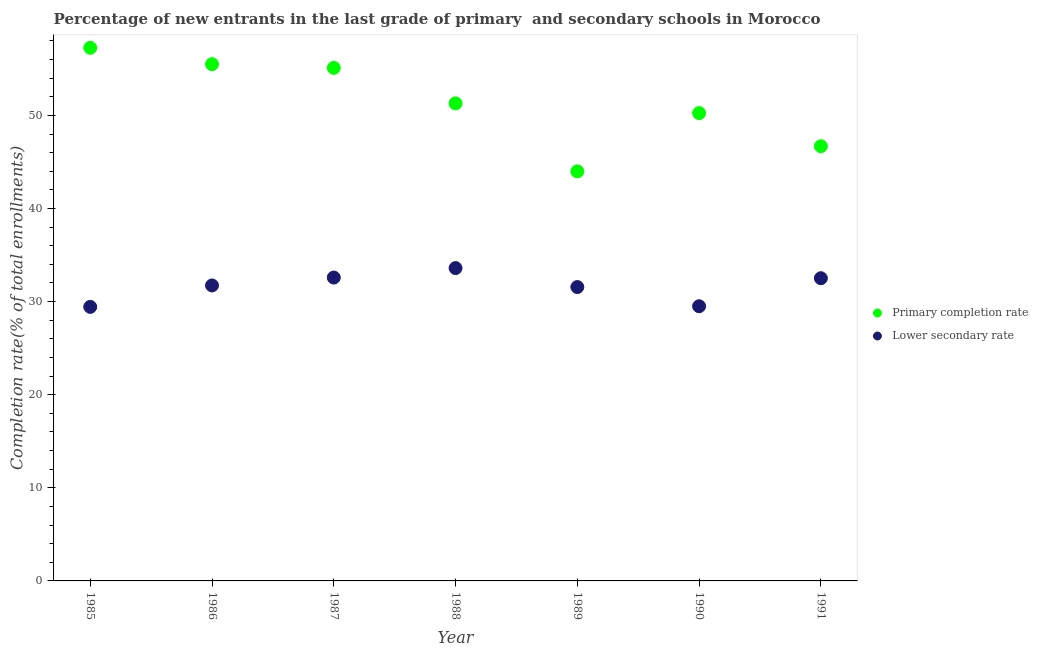How many different coloured dotlines are there?
Your response must be concise. 2. Is the number of dotlines equal to the number of legend labels?
Offer a terse response. Yes. What is the completion rate in secondary schools in 1991?
Keep it short and to the point. 32.51. Across all years, what is the maximum completion rate in secondary schools?
Give a very brief answer. 33.6. Across all years, what is the minimum completion rate in primary schools?
Make the answer very short. 43.99. In which year was the completion rate in secondary schools maximum?
Your answer should be compact. 1988. In which year was the completion rate in primary schools minimum?
Give a very brief answer. 1989. What is the total completion rate in secondary schools in the graph?
Give a very brief answer. 220.93. What is the difference between the completion rate in secondary schools in 1989 and that in 1991?
Offer a terse response. -0.95. What is the difference between the completion rate in primary schools in 1989 and the completion rate in secondary schools in 1986?
Your response must be concise. 12.25. What is the average completion rate in secondary schools per year?
Make the answer very short. 31.56. In the year 1985, what is the difference between the completion rate in secondary schools and completion rate in primary schools?
Provide a succinct answer. -27.82. In how many years, is the completion rate in secondary schools greater than 14 %?
Your response must be concise. 7. What is the ratio of the completion rate in primary schools in 1986 to that in 1989?
Provide a short and direct response. 1.26. Is the difference between the completion rate in primary schools in 1985 and 1989 greater than the difference between the completion rate in secondary schools in 1985 and 1989?
Your answer should be very brief. Yes. What is the difference between the highest and the second highest completion rate in primary schools?
Provide a short and direct response. 1.76. What is the difference between the highest and the lowest completion rate in primary schools?
Offer a terse response. 13.27. Does the completion rate in secondary schools monotonically increase over the years?
Your answer should be compact. No. Is the completion rate in primary schools strictly greater than the completion rate in secondary schools over the years?
Your answer should be compact. Yes. How many dotlines are there?
Keep it short and to the point. 2. Does the graph contain grids?
Offer a very short reply. No. Where does the legend appear in the graph?
Ensure brevity in your answer.  Center right. How are the legend labels stacked?
Give a very brief answer. Vertical. What is the title of the graph?
Make the answer very short. Percentage of new entrants in the last grade of primary  and secondary schools in Morocco. What is the label or title of the X-axis?
Ensure brevity in your answer.  Year. What is the label or title of the Y-axis?
Your response must be concise. Completion rate(% of total enrollments). What is the Completion rate(% of total enrollments) in Primary completion rate in 1985?
Offer a terse response. 57.26. What is the Completion rate(% of total enrollments) of Lower secondary rate in 1985?
Provide a short and direct response. 29.44. What is the Completion rate(% of total enrollments) of Primary completion rate in 1986?
Ensure brevity in your answer.  55.5. What is the Completion rate(% of total enrollments) in Lower secondary rate in 1986?
Ensure brevity in your answer.  31.73. What is the Completion rate(% of total enrollments) of Primary completion rate in 1987?
Your answer should be very brief. 55.1. What is the Completion rate(% of total enrollments) of Lower secondary rate in 1987?
Your answer should be very brief. 32.58. What is the Completion rate(% of total enrollments) of Primary completion rate in 1988?
Provide a short and direct response. 51.29. What is the Completion rate(% of total enrollments) of Lower secondary rate in 1988?
Offer a terse response. 33.6. What is the Completion rate(% of total enrollments) in Primary completion rate in 1989?
Your response must be concise. 43.99. What is the Completion rate(% of total enrollments) of Lower secondary rate in 1989?
Your answer should be compact. 31.56. What is the Completion rate(% of total enrollments) of Primary completion rate in 1990?
Make the answer very short. 50.25. What is the Completion rate(% of total enrollments) in Lower secondary rate in 1990?
Offer a very short reply. 29.5. What is the Completion rate(% of total enrollments) of Primary completion rate in 1991?
Give a very brief answer. 46.69. What is the Completion rate(% of total enrollments) of Lower secondary rate in 1991?
Your response must be concise. 32.51. Across all years, what is the maximum Completion rate(% of total enrollments) of Primary completion rate?
Your answer should be compact. 57.26. Across all years, what is the maximum Completion rate(% of total enrollments) in Lower secondary rate?
Your response must be concise. 33.6. Across all years, what is the minimum Completion rate(% of total enrollments) of Primary completion rate?
Give a very brief answer. 43.99. Across all years, what is the minimum Completion rate(% of total enrollments) in Lower secondary rate?
Your answer should be very brief. 29.44. What is the total Completion rate(% of total enrollments) of Primary completion rate in the graph?
Your answer should be very brief. 360.08. What is the total Completion rate(% of total enrollments) of Lower secondary rate in the graph?
Ensure brevity in your answer.  220.93. What is the difference between the Completion rate(% of total enrollments) of Primary completion rate in 1985 and that in 1986?
Make the answer very short. 1.76. What is the difference between the Completion rate(% of total enrollments) of Lower secondary rate in 1985 and that in 1986?
Ensure brevity in your answer.  -2.3. What is the difference between the Completion rate(% of total enrollments) in Primary completion rate in 1985 and that in 1987?
Offer a very short reply. 2.15. What is the difference between the Completion rate(% of total enrollments) of Lower secondary rate in 1985 and that in 1987?
Your answer should be very brief. -3.15. What is the difference between the Completion rate(% of total enrollments) in Primary completion rate in 1985 and that in 1988?
Provide a short and direct response. 5.97. What is the difference between the Completion rate(% of total enrollments) in Lower secondary rate in 1985 and that in 1988?
Make the answer very short. -4.17. What is the difference between the Completion rate(% of total enrollments) in Primary completion rate in 1985 and that in 1989?
Keep it short and to the point. 13.27. What is the difference between the Completion rate(% of total enrollments) of Lower secondary rate in 1985 and that in 1989?
Provide a succinct answer. -2.13. What is the difference between the Completion rate(% of total enrollments) in Primary completion rate in 1985 and that in 1990?
Provide a succinct answer. 7.01. What is the difference between the Completion rate(% of total enrollments) in Lower secondary rate in 1985 and that in 1990?
Provide a short and direct response. -0.07. What is the difference between the Completion rate(% of total enrollments) of Primary completion rate in 1985 and that in 1991?
Your answer should be compact. 10.57. What is the difference between the Completion rate(% of total enrollments) in Lower secondary rate in 1985 and that in 1991?
Keep it short and to the point. -3.08. What is the difference between the Completion rate(% of total enrollments) in Primary completion rate in 1986 and that in 1987?
Provide a short and direct response. 0.39. What is the difference between the Completion rate(% of total enrollments) of Lower secondary rate in 1986 and that in 1987?
Offer a very short reply. -0.85. What is the difference between the Completion rate(% of total enrollments) in Primary completion rate in 1986 and that in 1988?
Give a very brief answer. 4.21. What is the difference between the Completion rate(% of total enrollments) of Lower secondary rate in 1986 and that in 1988?
Your answer should be compact. -1.87. What is the difference between the Completion rate(% of total enrollments) of Primary completion rate in 1986 and that in 1989?
Give a very brief answer. 11.51. What is the difference between the Completion rate(% of total enrollments) of Lower secondary rate in 1986 and that in 1989?
Make the answer very short. 0.17. What is the difference between the Completion rate(% of total enrollments) of Primary completion rate in 1986 and that in 1990?
Give a very brief answer. 5.25. What is the difference between the Completion rate(% of total enrollments) in Lower secondary rate in 1986 and that in 1990?
Give a very brief answer. 2.23. What is the difference between the Completion rate(% of total enrollments) in Primary completion rate in 1986 and that in 1991?
Provide a succinct answer. 8.81. What is the difference between the Completion rate(% of total enrollments) in Lower secondary rate in 1986 and that in 1991?
Provide a short and direct response. -0.78. What is the difference between the Completion rate(% of total enrollments) in Primary completion rate in 1987 and that in 1988?
Keep it short and to the point. 3.81. What is the difference between the Completion rate(% of total enrollments) of Lower secondary rate in 1987 and that in 1988?
Keep it short and to the point. -1.02. What is the difference between the Completion rate(% of total enrollments) of Primary completion rate in 1987 and that in 1989?
Offer a very short reply. 11.12. What is the difference between the Completion rate(% of total enrollments) in Lower secondary rate in 1987 and that in 1989?
Provide a short and direct response. 1.02. What is the difference between the Completion rate(% of total enrollments) of Primary completion rate in 1987 and that in 1990?
Your answer should be compact. 4.86. What is the difference between the Completion rate(% of total enrollments) of Lower secondary rate in 1987 and that in 1990?
Keep it short and to the point. 3.08. What is the difference between the Completion rate(% of total enrollments) of Primary completion rate in 1987 and that in 1991?
Provide a succinct answer. 8.42. What is the difference between the Completion rate(% of total enrollments) of Lower secondary rate in 1987 and that in 1991?
Give a very brief answer. 0.07. What is the difference between the Completion rate(% of total enrollments) in Primary completion rate in 1988 and that in 1989?
Ensure brevity in your answer.  7.3. What is the difference between the Completion rate(% of total enrollments) of Lower secondary rate in 1988 and that in 1989?
Make the answer very short. 2.04. What is the difference between the Completion rate(% of total enrollments) of Primary completion rate in 1988 and that in 1990?
Provide a succinct answer. 1.05. What is the difference between the Completion rate(% of total enrollments) in Lower secondary rate in 1988 and that in 1990?
Provide a short and direct response. 4.1. What is the difference between the Completion rate(% of total enrollments) of Primary completion rate in 1988 and that in 1991?
Your response must be concise. 4.6. What is the difference between the Completion rate(% of total enrollments) of Lower secondary rate in 1988 and that in 1991?
Your answer should be compact. 1.09. What is the difference between the Completion rate(% of total enrollments) in Primary completion rate in 1989 and that in 1990?
Your response must be concise. -6.26. What is the difference between the Completion rate(% of total enrollments) in Lower secondary rate in 1989 and that in 1990?
Keep it short and to the point. 2.06. What is the difference between the Completion rate(% of total enrollments) of Primary completion rate in 1989 and that in 1991?
Offer a terse response. -2.7. What is the difference between the Completion rate(% of total enrollments) in Lower secondary rate in 1989 and that in 1991?
Your answer should be very brief. -0.95. What is the difference between the Completion rate(% of total enrollments) of Primary completion rate in 1990 and that in 1991?
Ensure brevity in your answer.  3.56. What is the difference between the Completion rate(% of total enrollments) in Lower secondary rate in 1990 and that in 1991?
Provide a succinct answer. -3.01. What is the difference between the Completion rate(% of total enrollments) of Primary completion rate in 1985 and the Completion rate(% of total enrollments) of Lower secondary rate in 1986?
Offer a very short reply. 25.52. What is the difference between the Completion rate(% of total enrollments) of Primary completion rate in 1985 and the Completion rate(% of total enrollments) of Lower secondary rate in 1987?
Offer a terse response. 24.67. What is the difference between the Completion rate(% of total enrollments) of Primary completion rate in 1985 and the Completion rate(% of total enrollments) of Lower secondary rate in 1988?
Provide a succinct answer. 23.66. What is the difference between the Completion rate(% of total enrollments) of Primary completion rate in 1985 and the Completion rate(% of total enrollments) of Lower secondary rate in 1989?
Provide a succinct answer. 25.69. What is the difference between the Completion rate(% of total enrollments) in Primary completion rate in 1985 and the Completion rate(% of total enrollments) in Lower secondary rate in 1990?
Provide a succinct answer. 27.76. What is the difference between the Completion rate(% of total enrollments) in Primary completion rate in 1985 and the Completion rate(% of total enrollments) in Lower secondary rate in 1991?
Offer a very short reply. 24.75. What is the difference between the Completion rate(% of total enrollments) in Primary completion rate in 1986 and the Completion rate(% of total enrollments) in Lower secondary rate in 1987?
Your answer should be compact. 22.92. What is the difference between the Completion rate(% of total enrollments) of Primary completion rate in 1986 and the Completion rate(% of total enrollments) of Lower secondary rate in 1988?
Your response must be concise. 21.9. What is the difference between the Completion rate(% of total enrollments) in Primary completion rate in 1986 and the Completion rate(% of total enrollments) in Lower secondary rate in 1989?
Keep it short and to the point. 23.94. What is the difference between the Completion rate(% of total enrollments) of Primary completion rate in 1986 and the Completion rate(% of total enrollments) of Lower secondary rate in 1990?
Ensure brevity in your answer.  26. What is the difference between the Completion rate(% of total enrollments) in Primary completion rate in 1986 and the Completion rate(% of total enrollments) in Lower secondary rate in 1991?
Make the answer very short. 22.99. What is the difference between the Completion rate(% of total enrollments) of Primary completion rate in 1987 and the Completion rate(% of total enrollments) of Lower secondary rate in 1988?
Ensure brevity in your answer.  21.5. What is the difference between the Completion rate(% of total enrollments) in Primary completion rate in 1987 and the Completion rate(% of total enrollments) in Lower secondary rate in 1989?
Offer a terse response. 23.54. What is the difference between the Completion rate(% of total enrollments) of Primary completion rate in 1987 and the Completion rate(% of total enrollments) of Lower secondary rate in 1990?
Provide a succinct answer. 25.6. What is the difference between the Completion rate(% of total enrollments) in Primary completion rate in 1987 and the Completion rate(% of total enrollments) in Lower secondary rate in 1991?
Make the answer very short. 22.59. What is the difference between the Completion rate(% of total enrollments) of Primary completion rate in 1988 and the Completion rate(% of total enrollments) of Lower secondary rate in 1989?
Give a very brief answer. 19.73. What is the difference between the Completion rate(% of total enrollments) in Primary completion rate in 1988 and the Completion rate(% of total enrollments) in Lower secondary rate in 1990?
Ensure brevity in your answer.  21.79. What is the difference between the Completion rate(% of total enrollments) of Primary completion rate in 1988 and the Completion rate(% of total enrollments) of Lower secondary rate in 1991?
Your answer should be very brief. 18.78. What is the difference between the Completion rate(% of total enrollments) of Primary completion rate in 1989 and the Completion rate(% of total enrollments) of Lower secondary rate in 1990?
Provide a succinct answer. 14.49. What is the difference between the Completion rate(% of total enrollments) of Primary completion rate in 1989 and the Completion rate(% of total enrollments) of Lower secondary rate in 1991?
Your answer should be very brief. 11.48. What is the difference between the Completion rate(% of total enrollments) of Primary completion rate in 1990 and the Completion rate(% of total enrollments) of Lower secondary rate in 1991?
Your answer should be very brief. 17.73. What is the average Completion rate(% of total enrollments) of Primary completion rate per year?
Your response must be concise. 51.44. What is the average Completion rate(% of total enrollments) of Lower secondary rate per year?
Ensure brevity in your answer.  31.56. In the year 1985, what is the difference between the Completion rate(% of total enrollments) in Primary completion rate and Completion rate(% of total enrollments) in Lower secondary rate?
Give a very brief answer. 27.82. In the year 1986, what is the difference between the Completion rate(% of total enrollments) of Primary completion rate and Completion rate(% of total enrollments) of Lower secondary rate?
Provide a short and direct response. 23.76. In the year 1987, what is the difference between the Completion rate(% of total enrollments) of Primary completion rate and Completion rate(% of total enrollments) of Lower secondary rate?
Offer a terse response. 22.52. In the year 1988, what is the difference between the Completion rate(% of total enrollments) in Primary completion rate and Completion rate(% of total enrollments) in Lower secondary rate?
Offer a very short reply. 17.69. In the year 1989, what is the difference between the Completion rate(% of total enrollments) of Primary completion rate and Completion rate(% of total enrollments) of Lower secondary rate?
Provide a succinct answer. 12.43. In the year 1990, what is the difference between the Completion rate(% of total enrollments) of Primary completion rate and Completion rate(% of total enrollments) of Lower secondary rate?
Make the answer very short. 20.75. In the year 1991, what is the difference between the Completion rate(% of total enrollments) in Primary completion rate and Completion rate(% of total enrollments) in Lower secondary rate?
Keep it short and to the point. 14.18. What is the ratio of the Completion rate(% of total enrollments) of Primary completion rate in 1985 to that in 1986?
Your answer should be very brief. 1.03. What is the ratio of the Completion rate(% of total enrollments) of Lower secondary rate in 1985 to that in 1986?
Offer a terse response. 0.93. What is the ratio of the Completion rate(% of total enrollments) in Primary completion rate in 1985 to that in 1987?
Offer a very short reply. 1.04. What is the ratio of the Completion rate(% of total enrollments) in Lower secondary rate in 1985 to that in 1987?
Make the answer very short. 0.9. What is the ratio of the Completion rate(% of total enrollments) in Primary completion rate in 1985 to that in 1988?
Provide a succinct answer. 1.12. What is the ratio of the Completion rate(% of total enrollments) in Lower secondary rate in 1985 to that in 1988?
Provide a short and direct response. 0.88. What is the ratio of the Completion rate(% of total enrollments) of Primary completion rate in 1985 to that in 1989?
Your answer should be compact. 1.3. What is the ratio of the Completion rate(% of total enrollments) of Lower secondary rate in 1985 to that in 1989?
Make the answer very short. 0.93. What is the ratio of the Completion rate(% of total enrollments) of Primary completion rate in 1985 to that in 1990?
Your answer should be compact. 1.14. What is the ratio of the Completion rate(% of total enrollments) in Primary completion rate in 1985 to that in 1991?
Make the answer very short. 1.23. What is the ratio of the Completion rate(% of total enrollments) in Lower secondary rate in 1985 to that in 1991?
Your response must be concise. 0.91. What is the ratio of the Completion rate(% of total enrollments) in Lower secondary rate in 1986 to that in 1987?
Offer a terse response. 0.97. What is the ratio of the Completion rate(% of total enrollments) of Primary completion rate in 1986 to that in 1988?
Provide a short and direct response. 1.08. What is the ratio of the Completion rate(% of total enrollments) of Primary completion rate in 1986 to that in 1989?
Keep it short and to the point. 1.26. What is the ratio of the Completion rate(% of total enrollments) in Lower secondary rate in 1986 to that in 1989?
Your response must be concise. 1.01. What is the ratio of the Completion rate(% of total enrollments) in Primary completion rate in 1986 to that in 1990?
Your answer should be very brief. 1.1. What is the ratio of the Completion rate(% of total enrollments) in Lower secondary rate in 1986 to that in 1990?
Provide a succinct answer. 1.08. What is the ratio of the Completion rate(% of total enrollments) in Primary completion rate in 1986 to that in 1991?
Offer a very short reply. 1.19. What is the ratio of the Completion rate(% of total enrollments) of Lower secondary rate in 1986 to that in 1991?
Ensure brevity in your answer.  0.98. What is the ratio of the Completion rate(% of total enrollments) of Primary completion rate in 1987 to that in 1988?
Ensure brevity in your answer.  1.07. What is the ratio of the Completion rate(% of total enrollments) in Lower secondary rate in 1987 to that in 1988?
Ensure brevity in your answer.  0.97. What is the ratio of the Completion rate(% of total enrollments) in Primary completion rate in 1987 to that in 1989?
Your answer should be compact. 1.25. What is the ratio of the Completion rate(% of total enrollments) of Lower secondary rate in 1987 to that in 1989?
Make the answer very short. 1.03. What is the ratio of the Completion rate(% of total enrollments) in Primary completion rate in 1987 to that in 1990?
Your answer should be very brief. 1.1. What is the ratio of the Completion rate(% of total enrollments) of Lower secondary rate in 1987 to that in 1990?
Your answer should be compact. 1.1. What is the ratio of the Completion rate(% of total enrollments) in Primary completion rate in 1987 to that in 1991?
Your answer should be compact. 1.18. What is the ratio of the Completion rate(% of total enrollments) of Lower secondary rate in 1987 to that in 1991?
Ensure brevity in your answer.  1. What is the ratio of the Completion rate(% of total enrollments) in Primary completion rate in 1988 to that in 1989?
Make the answer very short. 1.17. What is the ratio of the Completion rate(% of total enrollments) in Lower secondary rate in 1988 to that in 1989?
Offer a terse response. 1.06. What is the ratio of the Completion rate(% of total enrollments) of Primary completion rate in 1988 to that in 1990?
Keep it short and to the point. 1.02. What is the ratio of the Completion rate(% of total enrollments) in Lower secondary rate in 1988 to that in 1990?
Provide a short and direct response. 1.14. What is the ratio of the Completion rate(% of total enrollments) in Primary completion rate in 1988 to that in 1991?
Your answer should be compact. 1.1. What is the ratio of the Completion rate(% of total enrollments) in Lower secondary rate in 1988 to that in 1991?
Offer a very short reply. 1.03. What is the ratio of the Completion rate(% of total enrollments) in Primary completion rate in 1989 to that in 1990?
Make the answer very short. 0.88. What is the ratio of the Completion rate(% of total enrollments) in Lower secondary rate in 1989 to that in 1990?
Provide a short and direct response. 1.07. What is the ratio of the Completion rate(% of total enrollments) in Primary completion rate in 1989 to that in 1991?
Your answer should be very brief. 0.94. What is the ratio of the Completion rate(% of total enrollments) of Lower secondary rate in 1989 to that in 1991?
Your answer should be very brief. 0.97. What is the ratio of the Completion rate(% of total enrollments) in Primary completion rate in 1990 to that in 1991?
Offer a terse response. 1.08. What is the ratio of the Completion rate(% of total enrollments) of Lower secondary rate in 1990 to that in 1991?
Your response must be concise. 0.91. What is the difference between the highest and the second highest Completion rate(% of total enrollments) of Primary completion rate?
Offer a very short reply. 1.76. What is the difference between the highest and the second highest Completion rate(% of total enrollments) in Lower secondary rate?
Keep it short and to the point. 1.02. What is the difference between the highest and the lowest Completion rate(% of total enrollments) of Primary completion rate?
Provide a succinct answer. 13.27. What is the difference between the highest and the lowest Completion rate(% of total enrollments) of Lower secondary rate?
Make the answer very short. 4.17. 